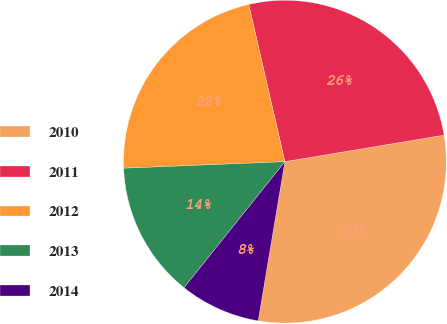Convert chart. <chart><loc_0><loc_0><loc_500><loc_500><pie_chart><fcel>2010<fcel>2011<fcel>2012<fcel>2013<fcel>2014<nl><fcel>30.27%<fcel>25.97%<fcel>22.04%<fcel>13.61%<fcel>8.1%<nl></chart> 